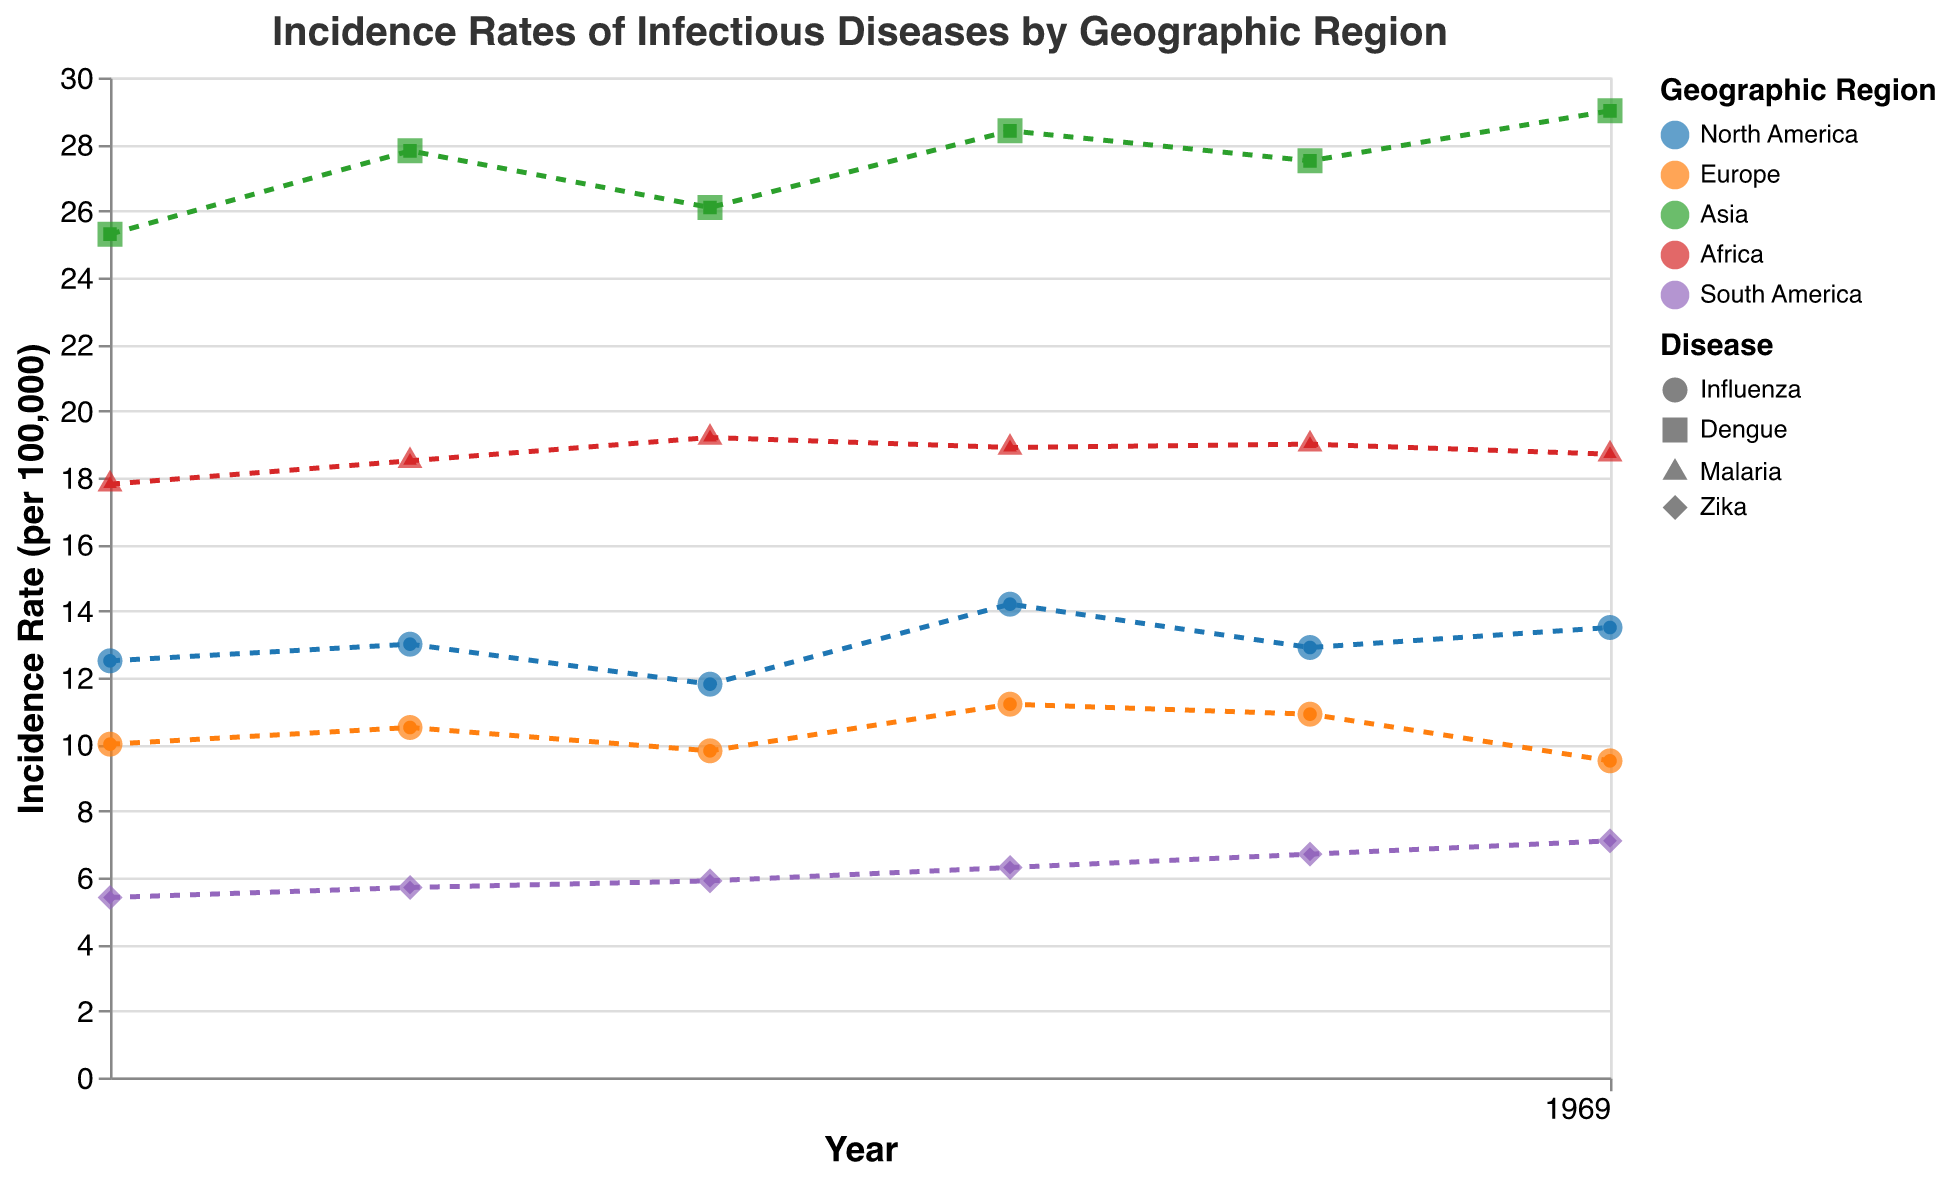What is the general trend of influenza incidence rates in North America from 2010 to 2015? The trend line for influenza in North America shows a slight overall increase from 2010 to 2015. Despite some fluctuations in the annual incidence rate, the general direction shows a rise.
Answer: Increasing Which region has the highest recorded incidence rate, and for which disease? By examining the plot, Asia has the highest recorded incidence rate, which is for Dengue in 2015 at 29.0 per 100,000.
Answer: Asia, Dengue Compare the incidence rates of Zika in South America in 2010 and 2015. What can you conclude? The incidence rate of Zika in South America in 2010 was 5.4, and in 2015 it was 7.1. This represents an increase of 1.7 over the five years, indicating a rising trend.
Answer: Increase How does the incidence rate of Malaria in Africa in 2013 compare to the rate in 2014? In 2013, the incidence rate of Malaria in Africa was 18.9 per 100,000, and in 2014 it was 19.0 per 100,000. The difference is minimal, showing relatively stable rates between these years.
Answer: Slight increase What is the average incidence rate of influenza in Europe over the period from 2010 to 2015? To find the average: (10.0 + 10.5 + 9.8 + 11.2 + 10.9 + 9.5) / 6 = 61.9 / 6 ≈ 10.32 per 100,000.
Answer: 10.32 per 100,000 Which disease in the data shows the most consistent trend over the years with the least fluctuation? From the scatter plot and trend lines, the incidence rate of Zika in South America shows the most consistent increase with the least fluctuation over the given period.
Answer: Zika, South America In which year did North America see the highest incidence rate of influenza? The highest incidence rate of influenza in North America is in 2013 with a rate of 14.2 per 100,000.
Answer: 2013 How does the change in the incidence rate of Dengue in Asia from 2012 to 2013 compare to the change from 2013 to 2014? The change from 2012 (26.1) to 2013 (28.4) is an increase of 2.3. The change from 2013 to 2014 (27.5) is a decrease of 0.9. Hence, the increase was larger from 2012 to 2013 compared to a slight decrease from 2013 to 2014.
Answer: Larger increase from 2012 to 2013 What pattern is observed in the incidence rates of diseases in Europe from 2010 to 2015? The incidence rates of influenza in Europe show some fluctuation with a general decreasing trend towards the end of the period.
Answer: Decreasing with fluctuations Between 2010 and 2015, which geographic region experienced the highest increase in the incidence rate of any disease, and what was the amount of the increase? Asia experienced the highest increase in the incidence rate of Dengue, from 25.3 in 2010 to 29.0 in 2015, which is an increase of 3.7 per 100,000.
Answer: Asia, 3.7 per 100,000 